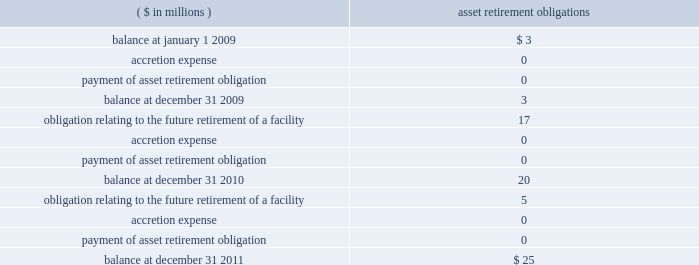Except for long-term debt , the carrying amounts of the company 2019s other financial instruments are measured at fair value or approximate fair value due to the short-term nature of these instruments .
Asset retirement obligations 2014the company records all known asset retirement obligations within other current liabilities for which the liability 2019s fair value can be reasonably estimated , including certain asbestos removal , asset decommissioning and contractual lease restoration obligations .
The changes in the asset retirement obligation carrying amounts during 2011 , 2010 and 2009 were as follows : ( $ in millions ) retirement obligations .
The company also has known conditional asset retirement obligations related to assets currently in use , such as certain asbestos remediation and asset decommissioning activities to be performed in the future , that were not reasonably estimable as of december 31 , 2011 and 2010 , due to insufficient information about the timing and method of settlement of the obligation .
Accordingly , the fair value of these obligations has not been recorded in the consolidated financial statements .
Environmental remediation and/or asset decommissioning of the relevant facilities may be required when the company ceases to utilize these facilities .
In addition , there may be conditional environmental asset retirement obligations that the company has not yet discovered .
Income taxes 2014income tax expense and other income tax related information contained in the financial statements for periods before the spin-off are presented as if the company filed its own tax returns on a stand-alone basis , while similar information for periods after the spin-off reflect the company 2019s positions to be filed in its own tax returns in the future .
Income tax expense and other related information are based on the prevailing statutory rates for u.s .
Federal income taxes and the composite state income tax rate for the company for each period presented .
State and local income and franchise tax provisions are allocable to contracts in process and , accordingly , are included in general and administrative expenses .
Deferred income taxes are recorded when revenues and expenses are recognized in different periods for financial statement purposes than for tax return purposes .
Deferred tax asset or liability account balances are calculated at the balance sheet date using current tax laws and rates in effect .
Determinations of the expected realizability of deferred tax assets and the need for any valuation allowances against these deferred tax assets were evaluated based upon the stand-alone tax attributes of the company , and an $ 18 million valuation allowance was deemed necessary as of december 31 , 2011 .
No valuation allowance was deemed necessary as of december 31 , 2010 .
Uncertain tax positions meeting the more-likely-than-not recognition threshold , based on the merits of the position , are recognized in the financial statements .
We recognize the amount of tax benefit that is greater than 50% ( 50 % ) likely to be realized upon ultimate settlement with the related tax authority .
If a tax position does not meet the minimum statutory threshold to avoid payment of penalties , we recognize an expense for the amount of the penalty in the period the tax position is claimed or expected to be claimed in our tax return .
Penalties , if probable and reasonably estimable , are recognized as a component of income tax expense .
We also recognize accrued interest related to uncertain tax positions in income tax expense .
The timing and amount of accrued interest is determined by the applicable tax law associated with an underpayment of income taxes .
See note 12 : income taxes .
Under existing gaap , changes in accruals associated with uncertainties are recorded in earnings in the period they are determined. .
What was the net increase in aro during the period , in millions? 
Computations: (25 - 3)
Answer: 22.0. 